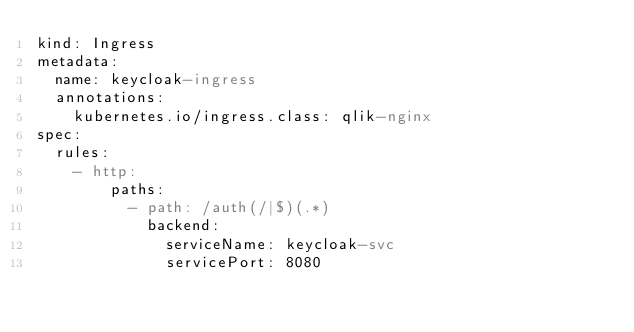Convert code to text. <code><loc_0><loc_0><loc_500><loc_500><_YAML_>kind: Ingress
metadata:
  name: keycloak-ingress
  annotations:
    kubernetes.io/ingress.class: qlik-nginx
spec:
  rules:
    - http:
        paths:
          - path: /auth(/|$)(.*)
            backend:
              serviceName: keycloak-svc
              servicePort: 8080

</code> 